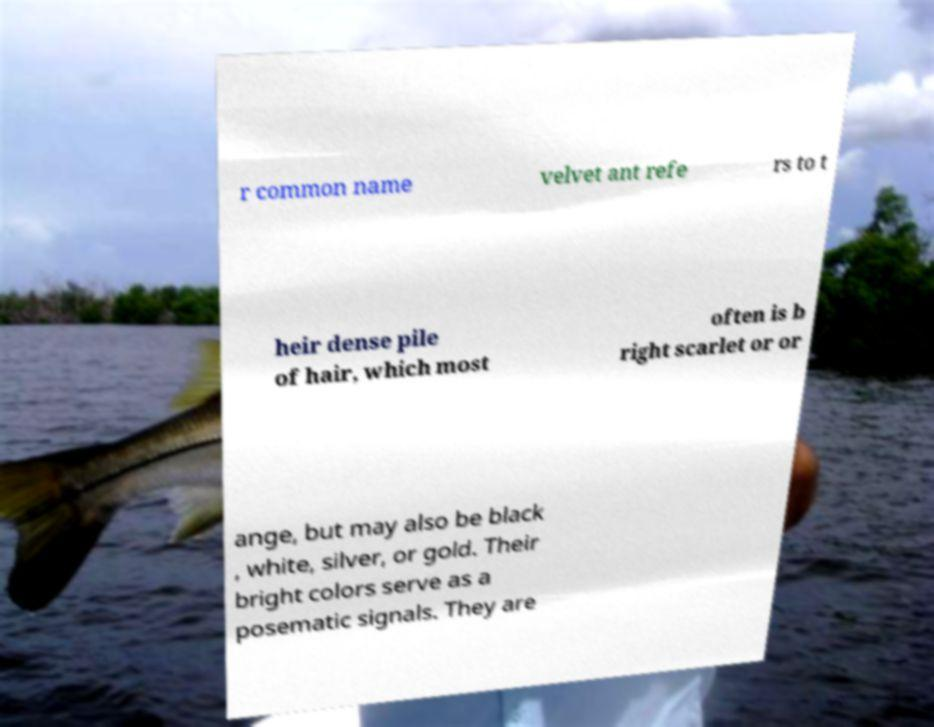I need the written content from this picture converted into text. Can you do that? r common name velvet ant refe rs to t heir dense pile of hair, which most often is b right scarlet or or ange, but may also be black , white, silver, or gold. Their bright colors serve as a posematic signals. They are 